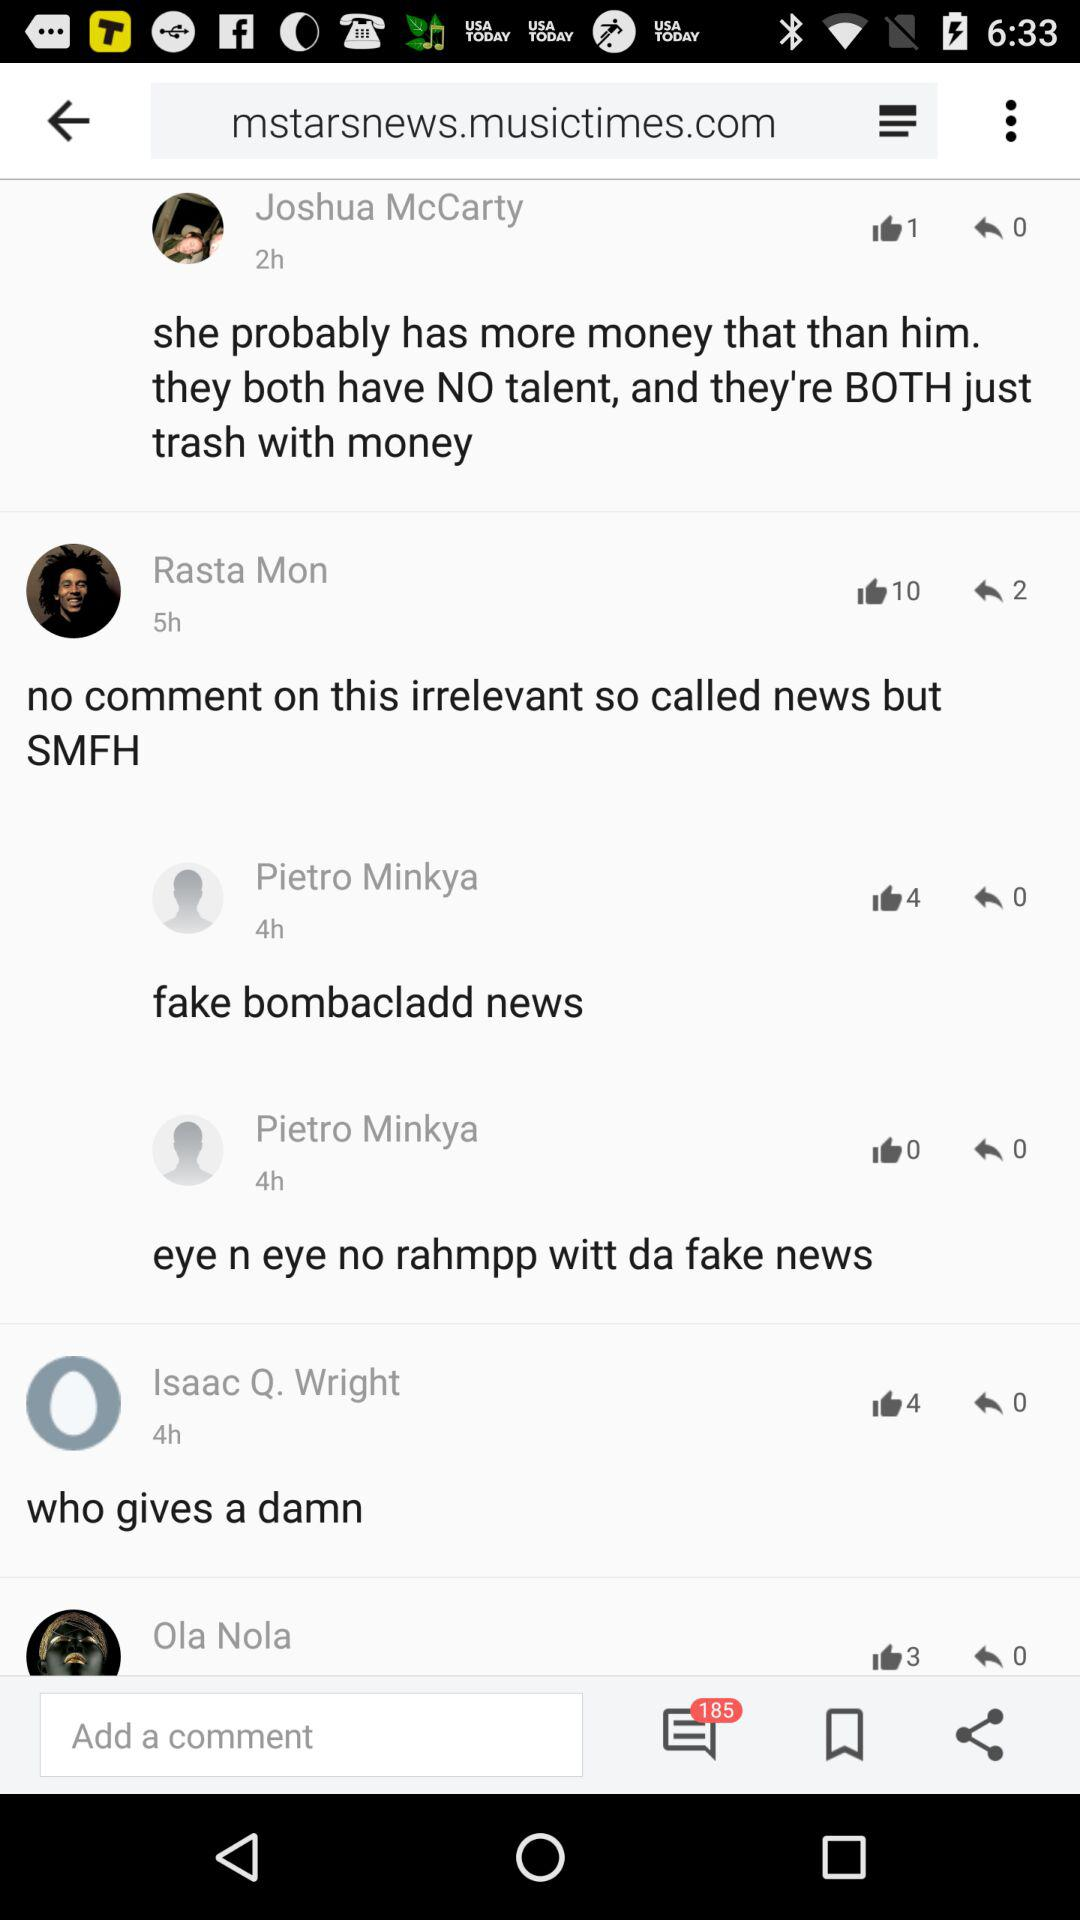How many people liked Rasta Mon's comment? The number of people who liked Rasta Mon's comment is 10. 